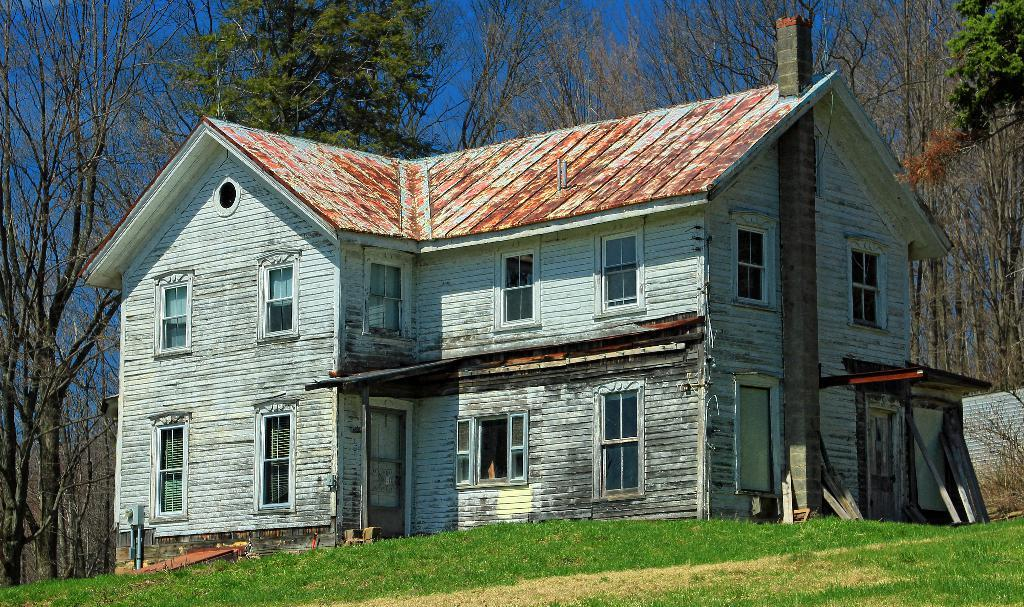What type of structure is present in the image? There is a building in the image. What type of vegetation can be seen in the image? There are trees in the image. What type of ground cover is visible in the image? There is grass visible in the image. What example of a fictional character can be seen interacting with the building in the image? There are no fictional characters present in the image, and therefore no such interaction can be observed. 